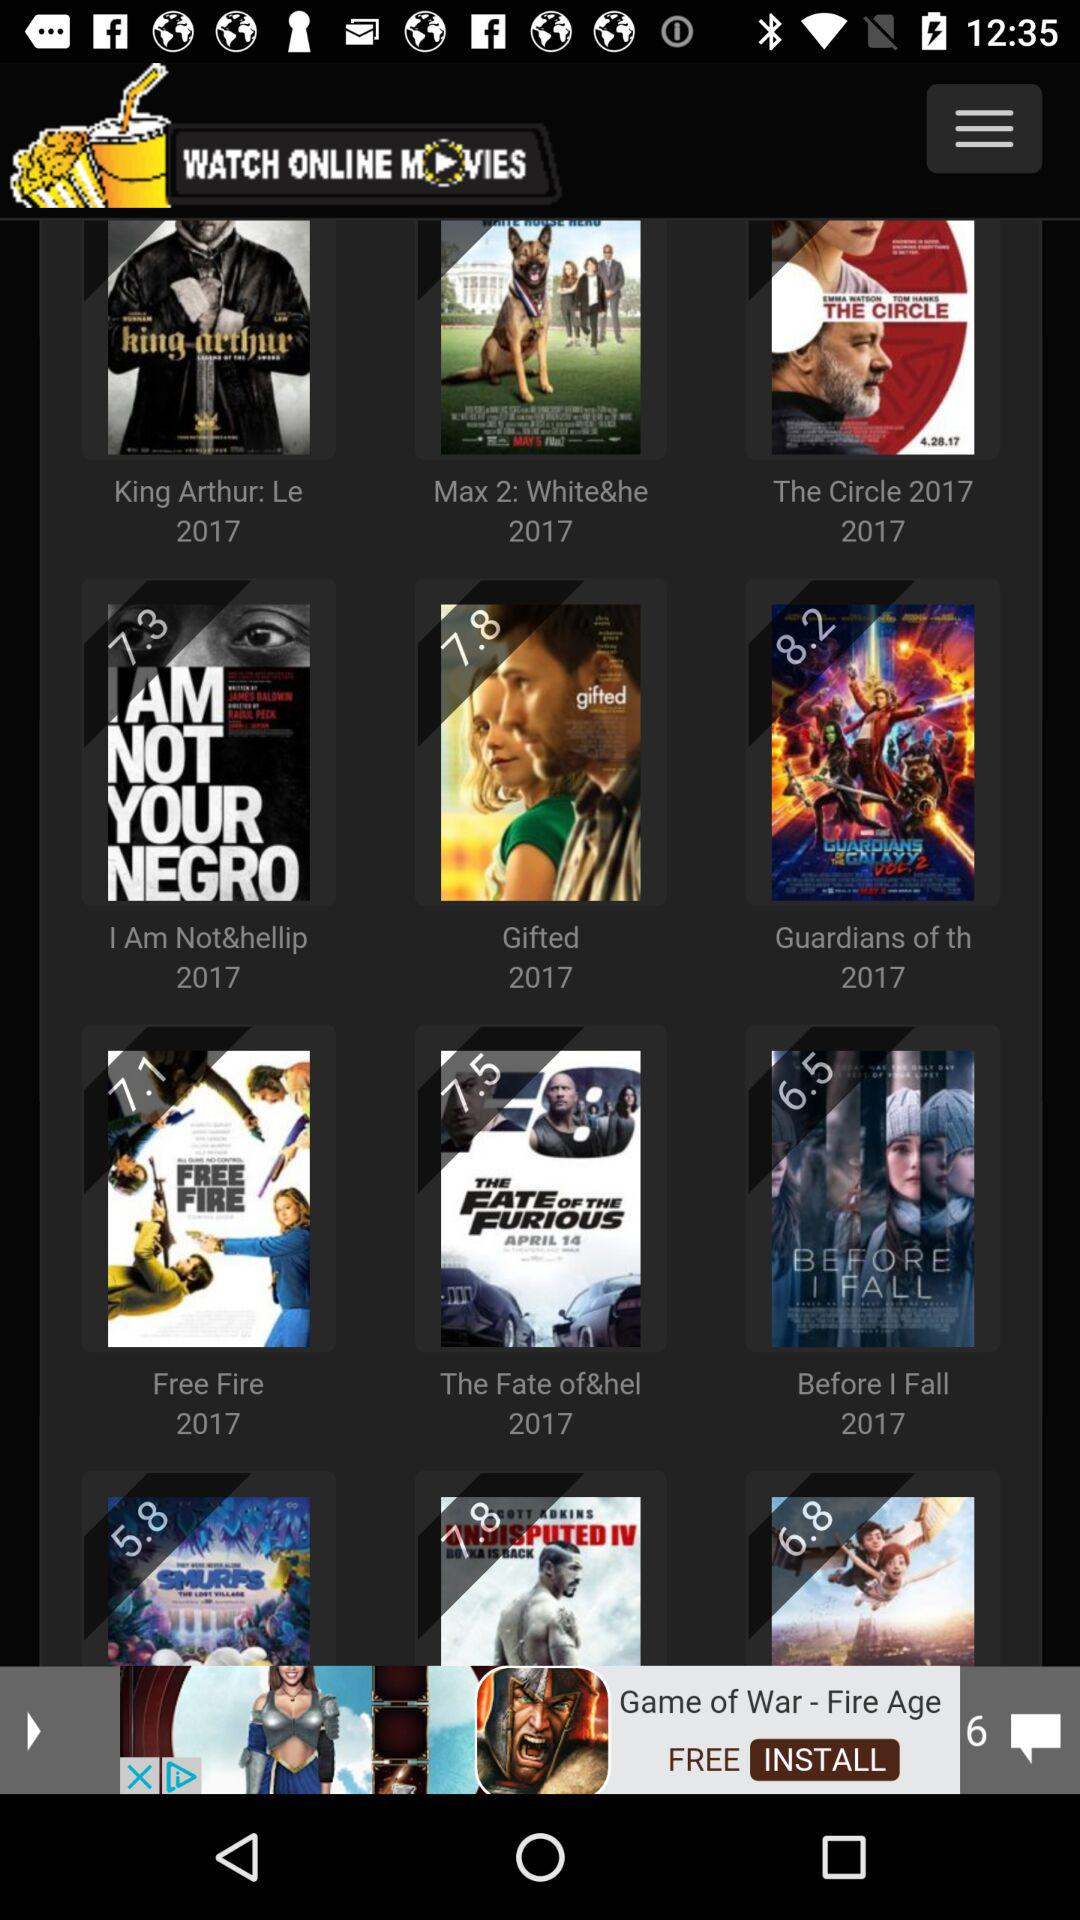What is the rating of the movie "Gifted"? The rating of the movie "Gifted" is 7.8. 